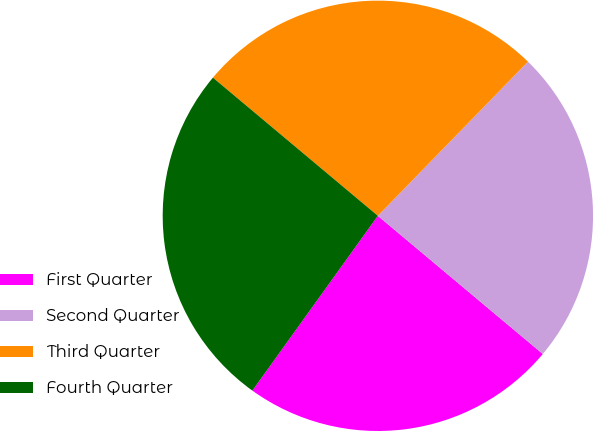Convert chart to OTSL. <chart><loc_0><loc_0><loc_500><loc_500><pie_chart><fcel>First Quarter<fcel>Second Quarter<fcel>Third Quarter<fcel>Fourth Quarter<nl><fcel>23.81%<fcel>23.81%<fcel>26.19%<fcel>26.19%<nl></chart> 